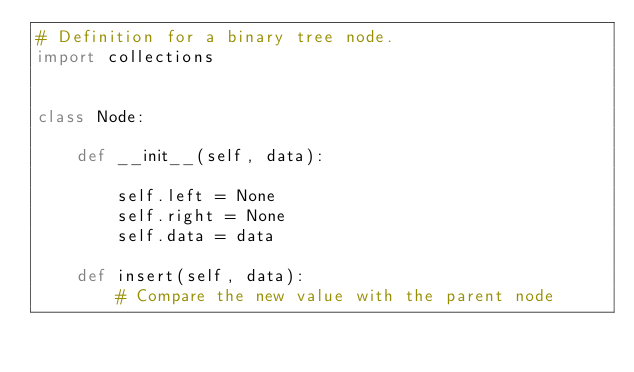<code> <loc_0><loc_0><loc_500><loc_500><_Python_># Definition for a binary tree node.
import collections


class Node:

    def __init__(self, data):

        self.left = None
        self.right = None
        self.data = data

    def insert(self, data):
        # Compare the new value with the parent node</code> 